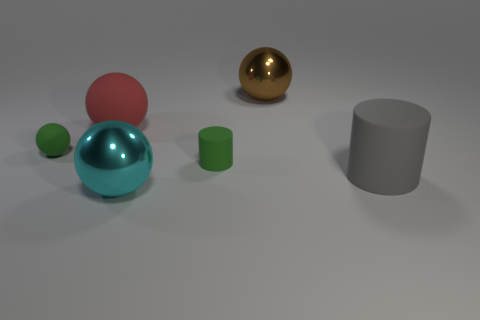Could you propose a practical use for each object shown? Certainly! The aqua blue object could serve as a decorative paperweight, the red sphere might be a child's toy ball, the small green cylinder could be a container for small items, the gray cylinder looks to be a pencil holder, and the brown shiny sphere could either be a decorative ornament or part of a larger mechanism or structure. 